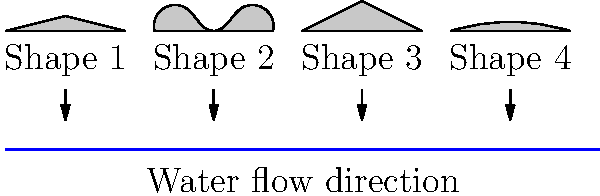As a retired professional slalom canoeist, you're asked to analyze different kayak designs for a new competition. Which of the four shapes shown above would be the most aerodynamic and efficient when rotated 180 degrees to face the direction of water flow? To solve this problem, we need to mentally rotate each kayak shape 180 degrees and evaluate its aerodynamic properties. Let's go through each shape:

1. Shape 1: When rotated, it would have a pointed front and a flat back. This is not ideal for aerodynamics as it creates turbulence behind the kayak.

2. Shape 2: When rotated, it would have a rounded front and back. This shape reduces drag both at the front and rear of the kayak, making it more aerodynamic.

3. Shape 3: When rotated, it would have a very sharp point at the front and a wide, flat back. While the sharp front cuts through water well, the flat back creates significant drag.

4. Shape 4: When rotated, it would have a gently curved front and back. This shape is aerodynamic, but not as efficient as Shape 2.

The most aerodynamic shape should have a streamlined form that minimizes water resistance both at the front and back. Shape 2, when rotated, provides the best balance of these features. Its rounded front will part the water smoothly, and its rounded back will reduce turbulence and drag behind the kayak.

In fluid dynamics, this shape is similar to a "tear-drop" profile, which is known to be one of the most aerodynamic shapes. It allows for smooth flow of water around the kayak, minimizing energy loss due to turbulence.
Answer: Shape 2 